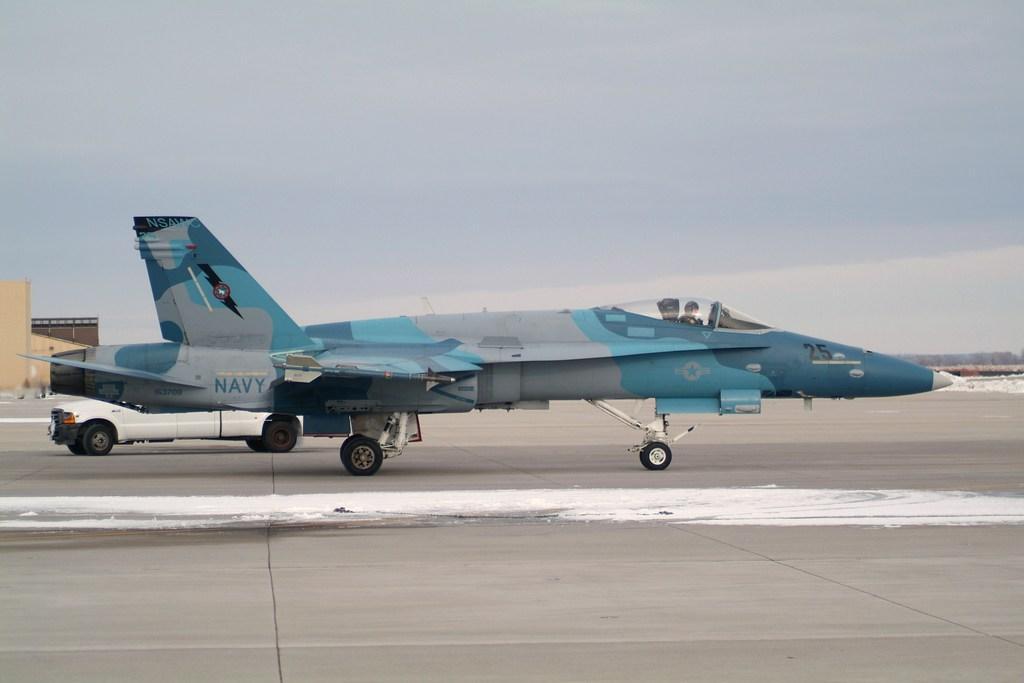Could you give a brief overview of what you see in this image? In this picture, we can see an aircraft, a vehicle, road, buildings and the sky with clouds. 